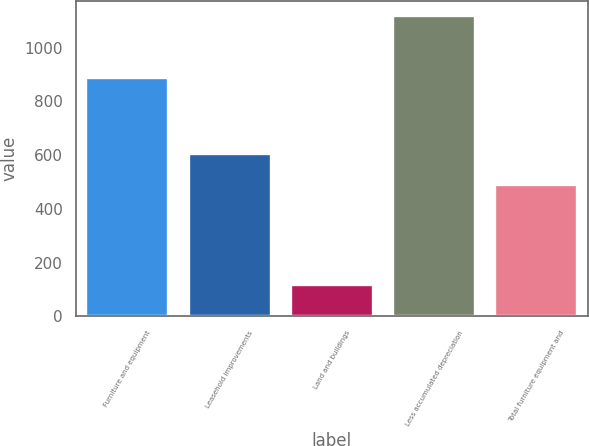Convert chart. <chart><loc_0><loc_0><loc_500><loc_500><bar_chart><fcel>Furniture and equipment<fcel>Leasehold improvements<fcel>Land and buildings<fcel>Less accumulated depreciation<fcel>Total furniture equipment and<nl><fcel>886.2<fcel>604.6<fcel>118.4<fcel>1119.1<fcel>490.1<nl></chart> 